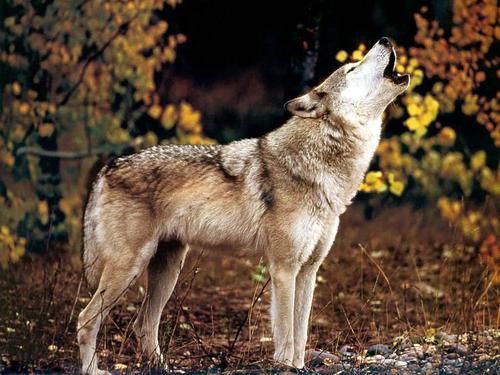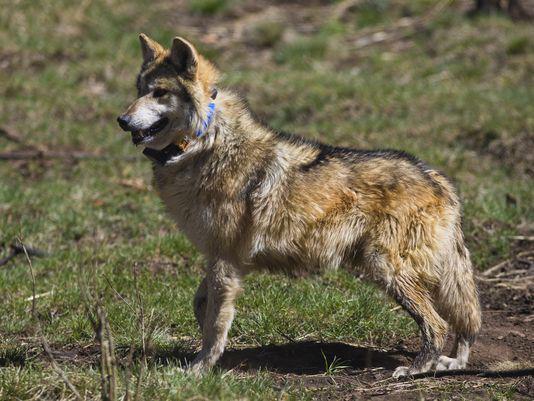The first image is the image on the left, the second image is the image on the right. For the images displayed, is the sentence "One image shows a leftward-facing wolf standing in a green grassy area." factually correct? Answer yes or no. Yes. The first image is the image on the left, the second image is the image on the right. Given the left and right images, does the statement "The wolf in one of the images is standing in the green grass." hold true? Answer yes or no. Yes. 